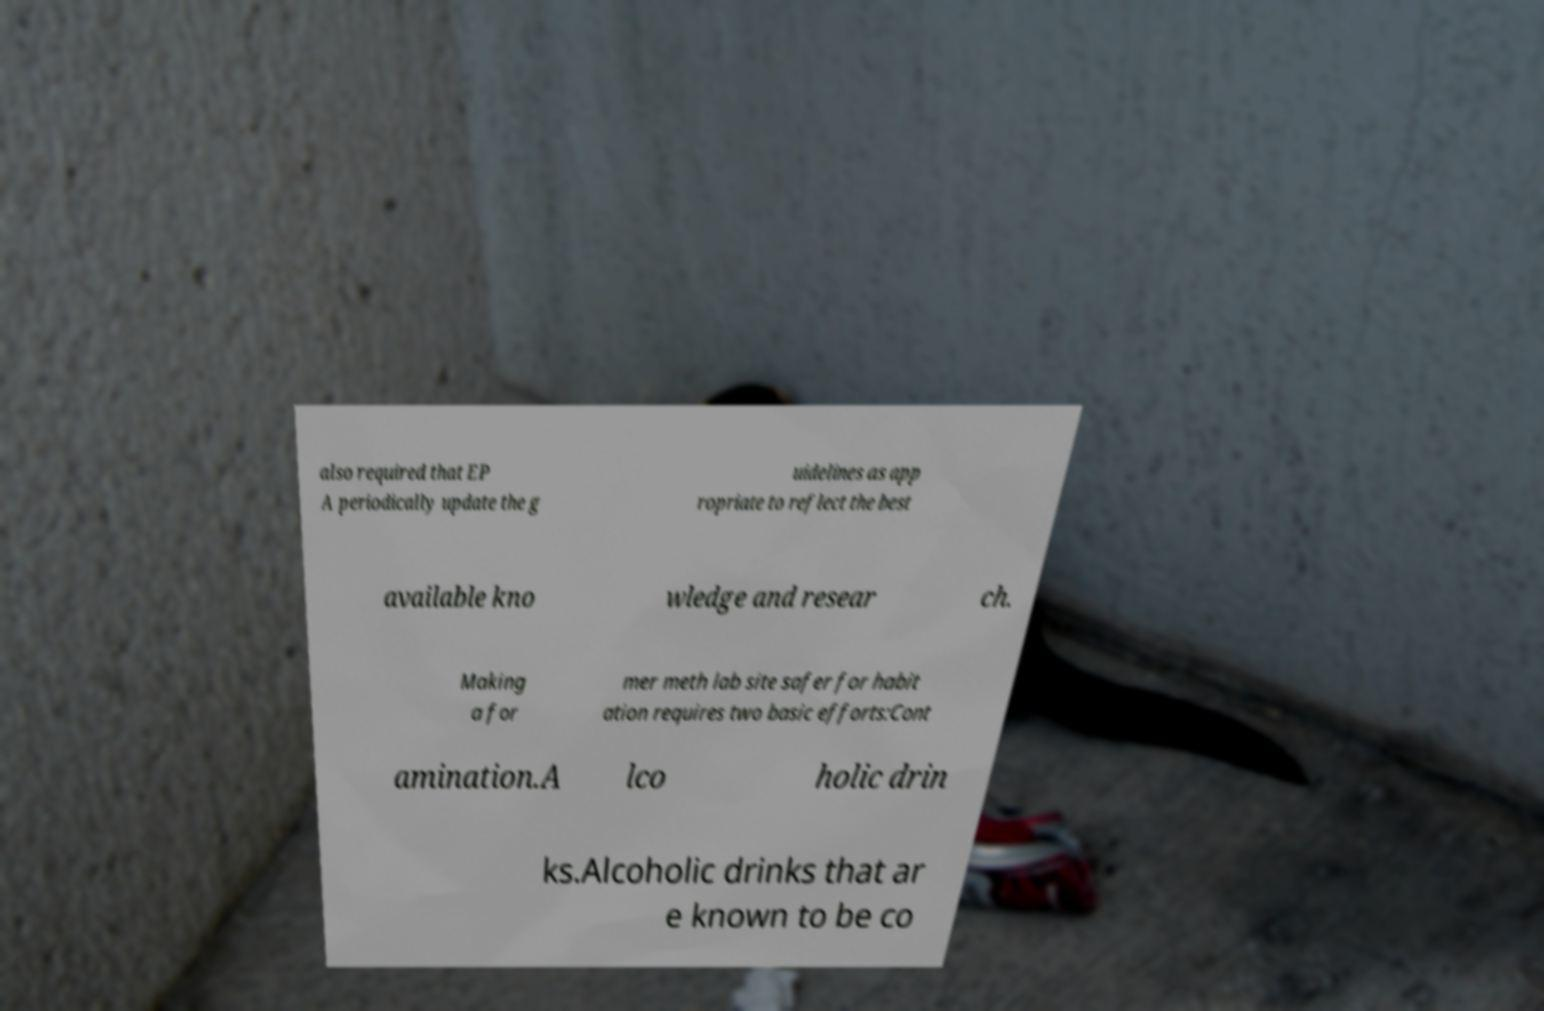Please identify and transcribe the text found in this image. also required that EP A periodically update the g uidelines as app ropriate to reflect the best available kno wledge and resear ch. Making a for mer meth lab site safer for habit ation requires two basic efforts:Cont amination.A lco holic drin ks.Alcoholic drinks that ar e known to be co 